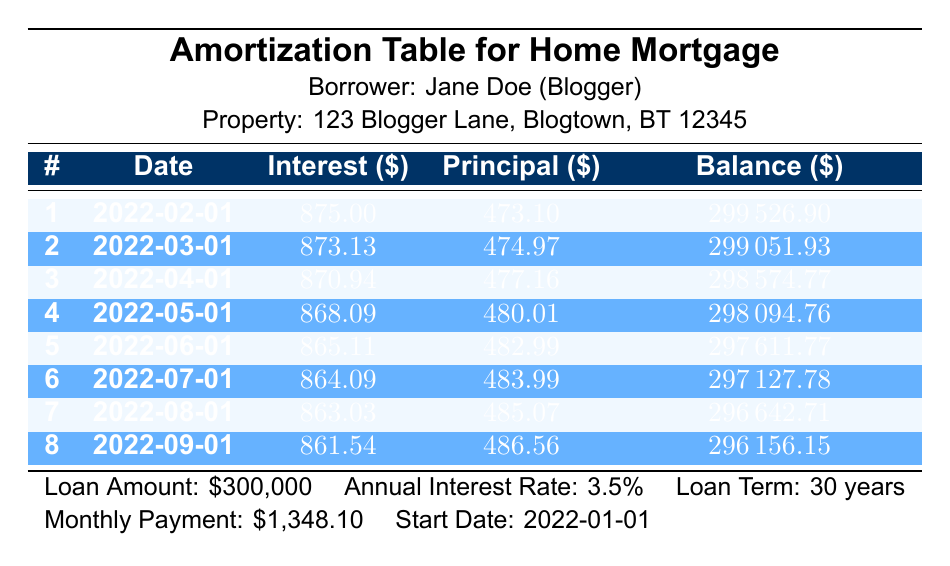What is the amount of the first interest payment? The first payment's interest amount can be found in the "Interest ($)" column of the first row. It states 875.00.
Answer: 875.00 What is the remaining balance after the second payment? The remaining balance after the second payment is listed in the "Balance ($)" column of the second row, which shows 299051.93.
Answer: 299051.93 How much total principal has been paid after the first three payments? To calculate the total principal paid, sum the "Principal ($)" values from the first three rows: 473.10 + 474.97 + 477.16 = 1425.23.
Answer: 1425.23 Is the monthly payment the same for all months? The monthly payment is constant at 1348.10 throughout the payments, as indicated in the loan details at the bottom of the table.
Answer: Yes What is the decrease in the remaining balance from the first to the fourth payment? The remaining balance decreased from 299526.90 (after the first payment) to 298094.76 (after the fourth payment). The decrease is calculated as 299526.90 - 298094.76 = 1432.14.
Answer: 1432.14 What is the average interest payment for the first eight payments? To find the average interest payment, sum the interest payments and divide by the number of payments. The sum of interest for the first eight payments is (875.00 + 873.13 + 870.94 + 868.09 + 865.11 + 864.09 + 863.03 + 861.54) = 6175.93. Dividing 6175.93 by 8 gives an average of 771.99.
Answer: 771.99 Is the total interest payment after the first six payments more than 5200? The total interest payment for the first six is 875 + 873.13 + 870.94 + 868.09 + 865.11 + 864.09 = 5216.36, which is greater than 5200.
Answer: Yes How much does the principal payment increase from the first to the fourth payment? The principal payment in the first payment is 473.10 and in the fourth is 480.01. The increase is calculated as 480.01 - 473.10 = 6.91.
Answer: 6.91 